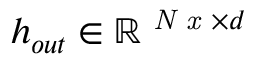<formula> <loc_0><loc_0><loc_500><loc_500>h _ { o u t } \in \mathbb { R } ^ { N x \times d }</formula> 